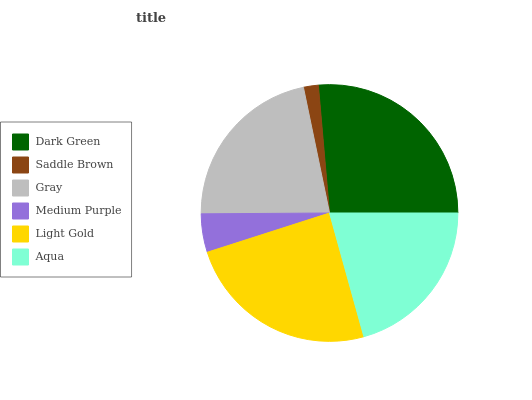Is Saddle Brown the minimum?
Answer yes or no. Yes. Is Dark Green the maximum?
Answer yes or no. Yes. Is Gray the minimum?
Answer yes or no. No. Is Gray the maximum?
Answer yes or no. No. Is Gray greater than Saddle Brown?
Answer yes or no. Yes. Is Saddle Brown less than Gray?
Answer yes or no. Yes. Is Saddle Brown greater than Gray?
Answer yes or no. No. Is Gray less than Saddle Brown?
Answer yes or no. No. Is Gray the high median?
Answer yes or no. Yes. Is Aqua the low median?
Answer yes or no. Yes. Is Saddle Brown the high median?
Answer yes or no. No. Is Medium Purple the low median?
Answer yes or no. No. 